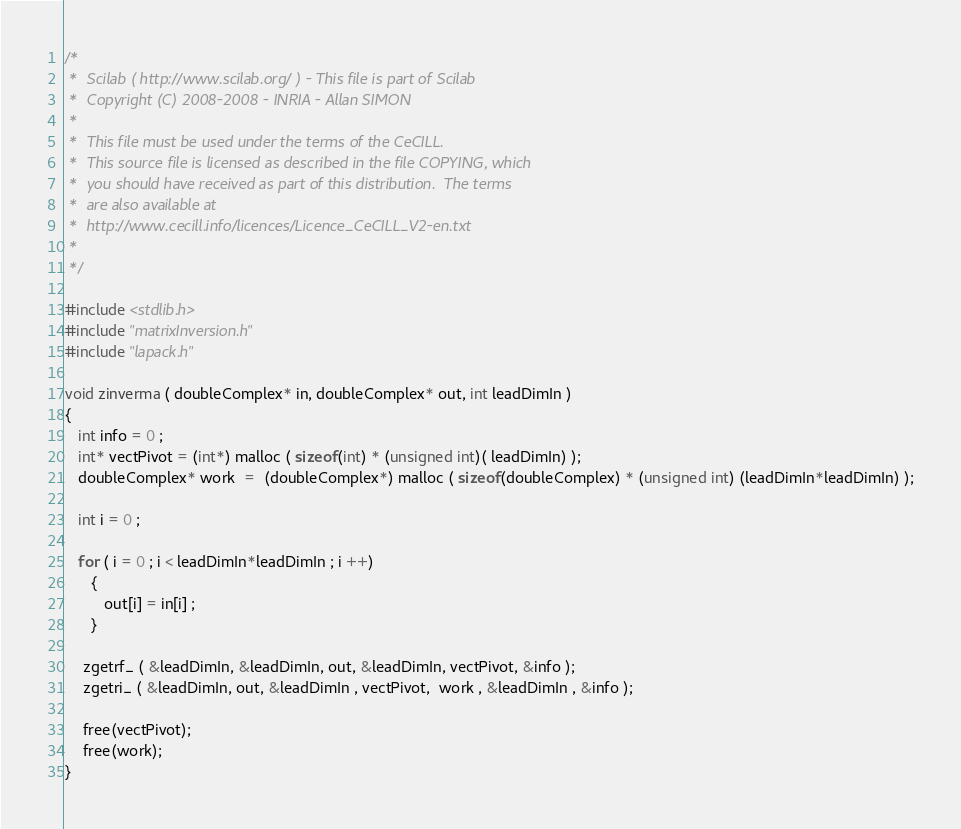Convert code to text. <code><loc_0><loc_0><loc_500><loc_500><_C_>/*
 *  Scilab ( http://www.scilab.org/ ) - This file is part of Scilab
 *  Copyright (C) 2008-2008 - INRIA - Allan SIMON
 *
 *  This file must be used under the terms of the CeCILL.
 *  This source file is licensed as described in the file COPYING, which
 *  you should have received as part of this distribution.  The terms
 *  are also available at
 *  http://www.cecill.info/licences/Licence_CeCILL_V2-en.txt
 *
 */

#include <stdlib.h>
#include "matrixInversion.h" 
#include "lapack.h"

void zinverma ( doubleComplex* in, doubleComplex* out, int leadDimIn )
{
   int info = 0 ;
   int* vectPivot = (int*) malloc ( sizeof(int) * (unsigned int)( leadDimIn) );
   doubleComplex* work  =  (doubleComplex*) malloc ( sizeof(doubleComplex) * (unsigned int) (leadDimIn*leadDimIn) );

   int i = 0 ;

   for ( i = 0 ; i < leadDimIn*leadDimIn ; i ++)
      {
         out[i] = in[i] ;
      }

    zgetrf_ ( &leadDimIn, &leadDimIn, out, &leadDimIn, vectPivot, &info );  
    zgetri_ ( &leadDimIn, out, &leadDimIn , vectPivot,  work , &leadDimIn , &info ); 

    free(vectPivot);
    free(work);
}

</code> 